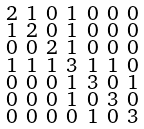Convert formula to latex. <formula><loc_0><loc_0><loc_500><loc_500>\begin{smallmatrix} 2 & 1 & 0 & 1 & 0 & 0 & 0 \\ 1 & 2 & 0 & 1 & 0 & 0 & 0 \\ 0 & 0 & 2 & 1 & 0 & 0 & 0 \\ 1 & 1 & 1 & 3 & 1 & 1 & 0 \\ 0 & 0 & 0 & 1 & 3 & 0 & 1 \\ 0 & 0 & 0 & 1 & 0 & 3 & 0 \\ 0 & 0 & 0 & 0 & 1 & 0 & 3 \end{smallmatrix}</formula> 